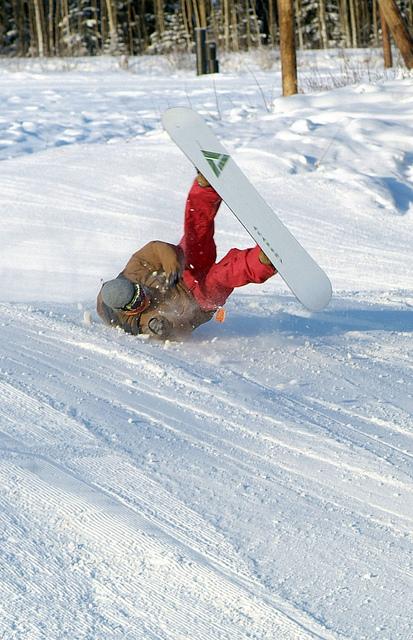Did the man just wipe out?
Be succinct. Yes. Is he going uphill or downhill?
Answer briefly. Downhill. What symbol is on the bottom of the snowboard?
Answer briefly. Triangle. 